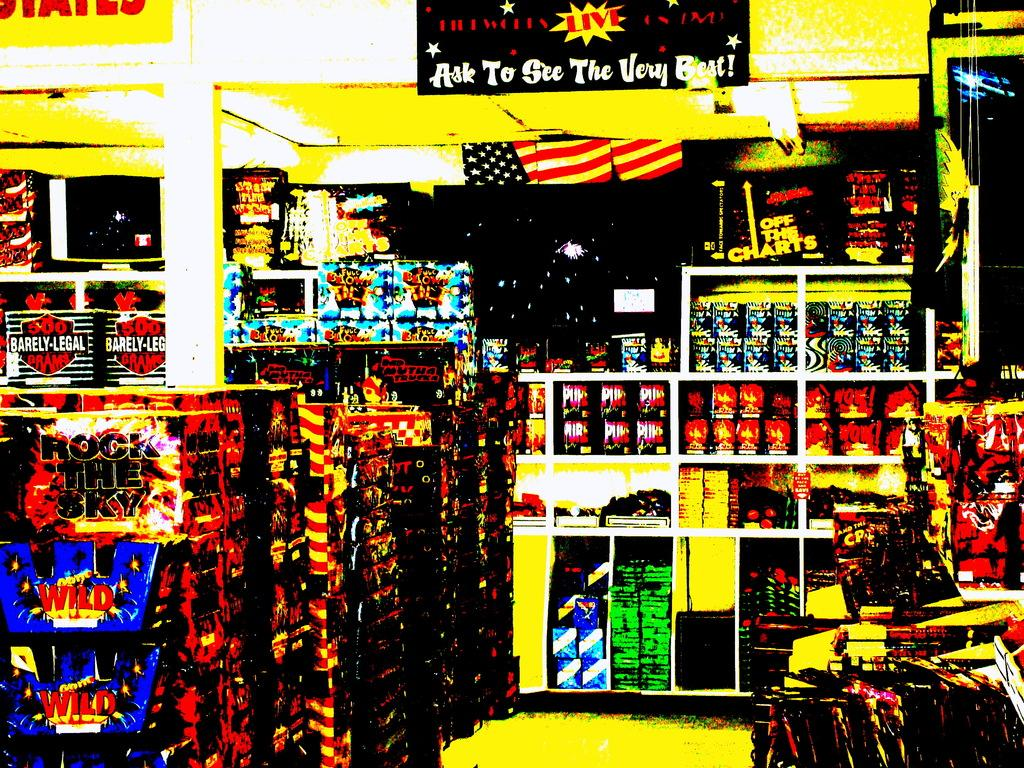<image>
Describe the image concisely. The interior of a store has a banner that says "ask to see the very best!" 